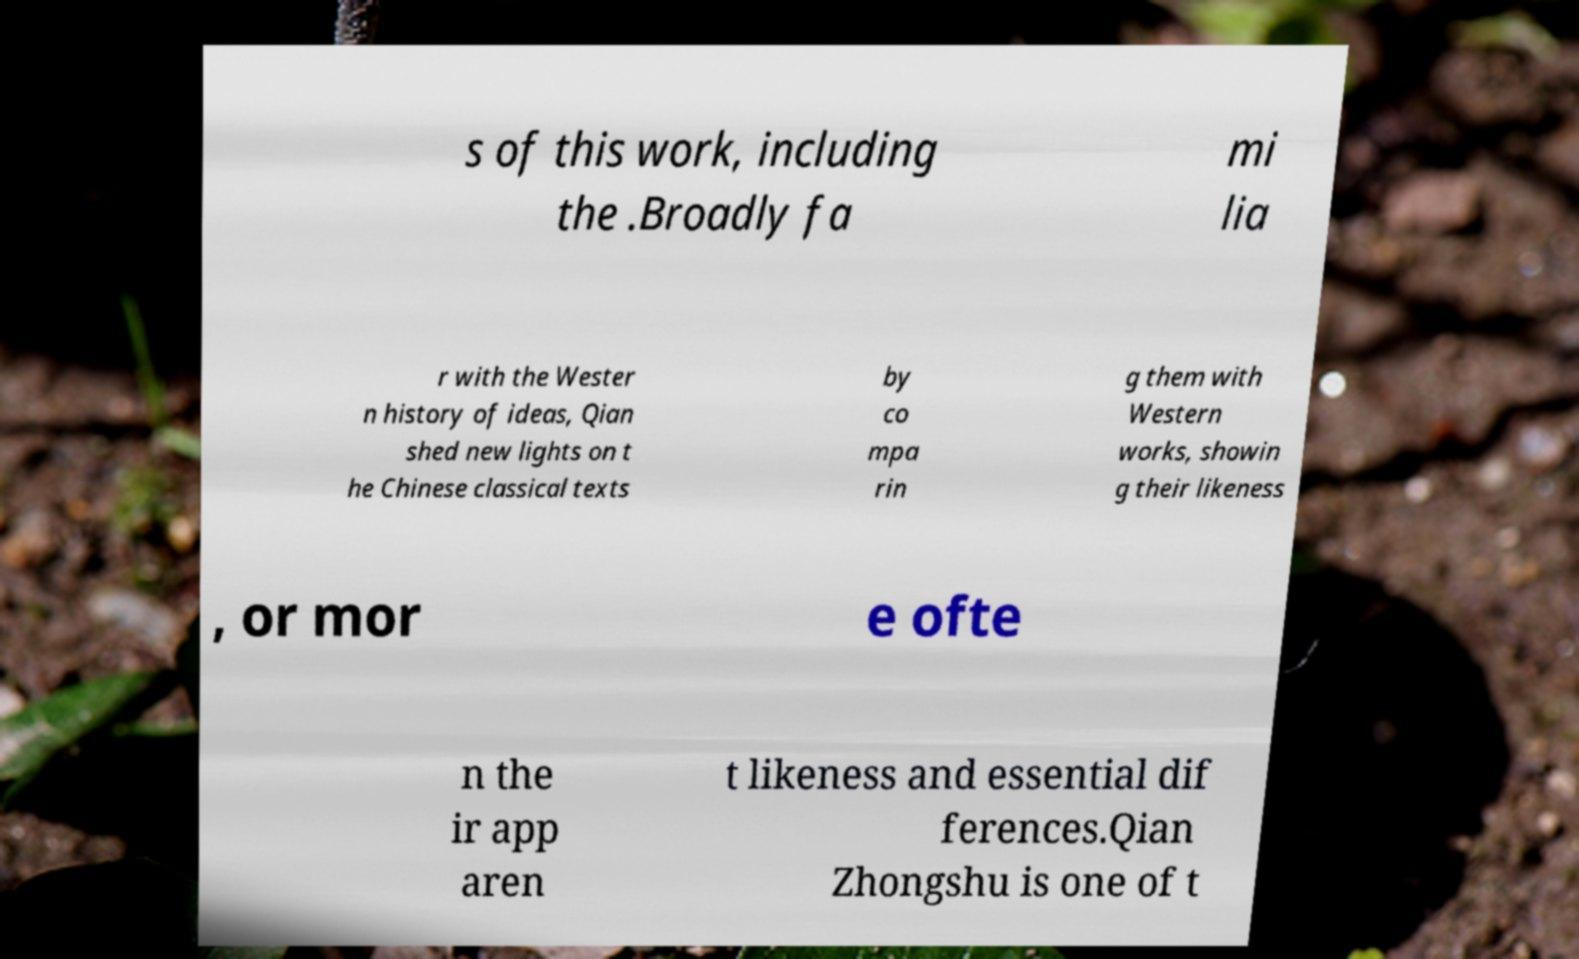Could you assist in decoding the text presented in this image and type it out clearly? s of this work, including the .Broadly fa mi lia r with the Wester n history of ideas, Qian shed new lights on t he Chinese classical texts by co mpa rin g them with Western works, showin g their likeness , or mor e ofte n the ir app aren t likeness and essential dif ferences.Qian Zhongshu is one of t 